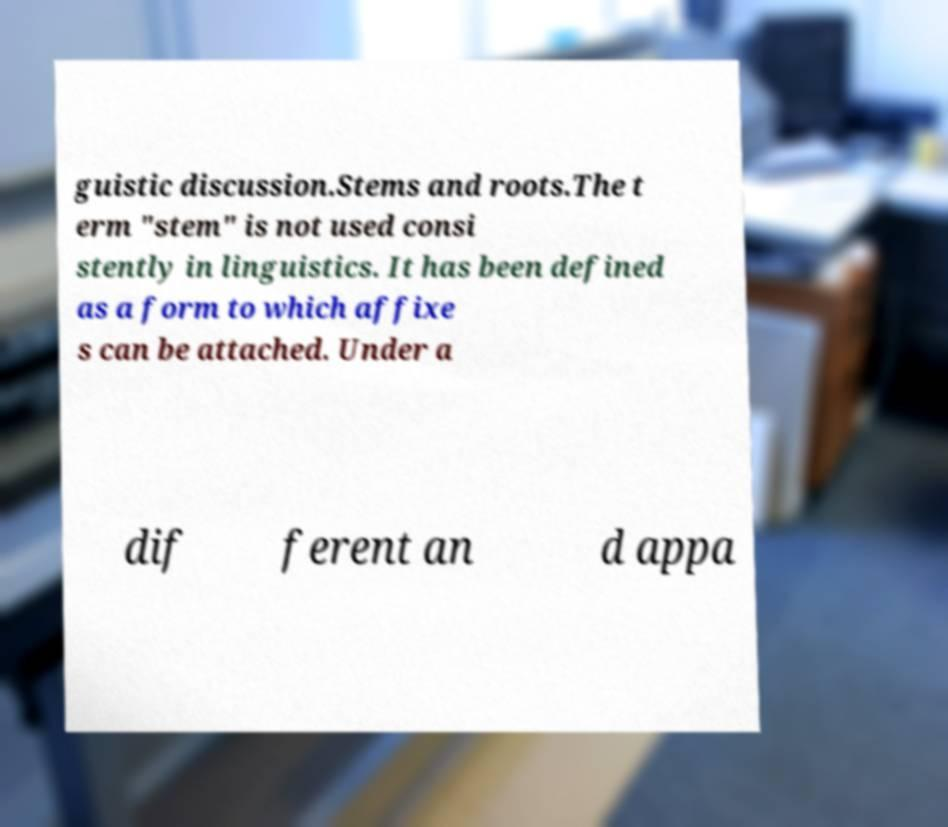Can you accurately transcribe the text from the provided image for me? guistic discussion.Stems and roots.The t erm "stem" is not used consi stently in linguistics. It has been defined as a form to which affixe s can be attached. Under a dif ferent an d appa 